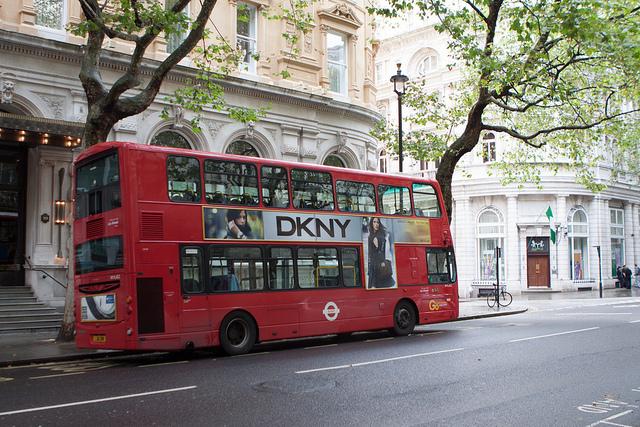Are the street lamps on?
Write a very short answer. No. What does the bus have written on it?
Concise answer only. Dkny. Is this America?
Answer briefly. No. What is the name of the designer who created the label advertised here?
Give a very brief answer. Dkny. What does the side of the bus say?
Short answer required. Dkny. Is the building in the background empty?
Give a very brief answer. No. 